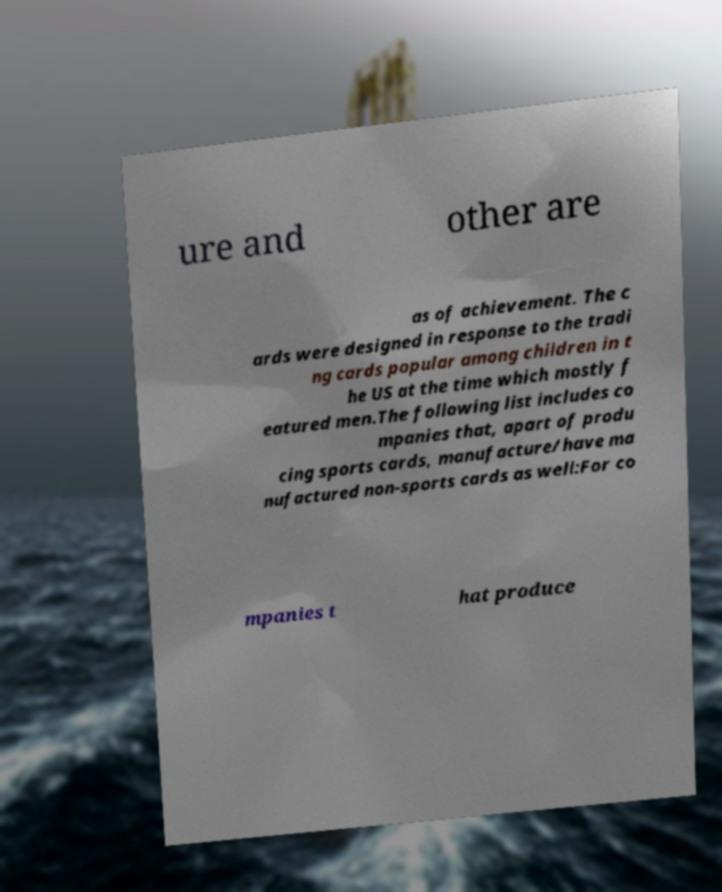Can you accurately transcribe the text from the provided image for me? ure and other are as of achievement. The c ards were designed in response to the tradi ng cards popular among children in t he US at the time which mostly f eatured men.The following list includes co mpanies that, apart of produ cing sports cards, manufacture/have ma nufactured non-sports cards as well:For co mpanies t hat produce 